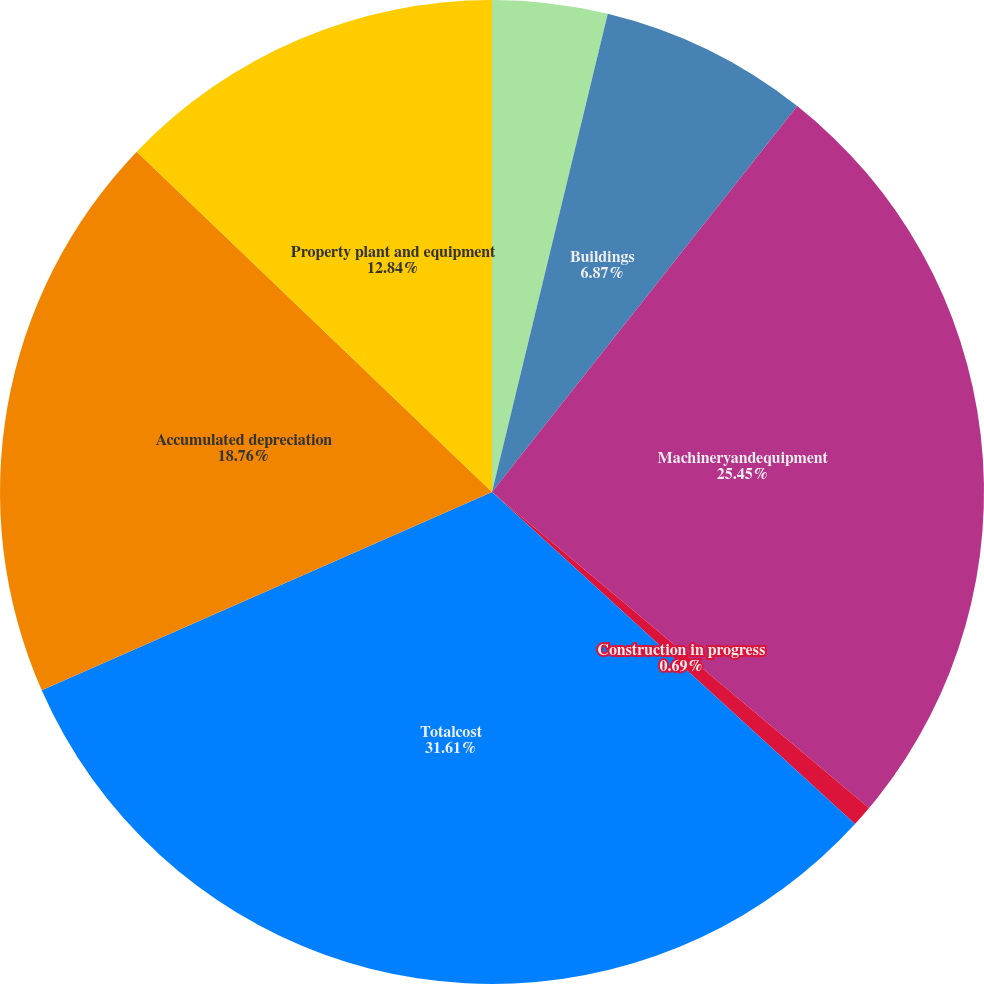Convert chart to OTSL. <chart><loc_0><loc_0><loc_500><loc_500><pie_chart><fcel>Landandlandimprovements<fcel>Buildings<fcel>Machineryandequipment<fcel>Construction in progress<fcel>Totalcost<fcel>Accumulated depreciation<fcel>Property plant and equipment<nl><fcel>3.78%<fcel>6.87%<fcel>25.45%<fcel>0.69%<fcel>31.6%<fcel>18.76%<fcel>12.84%<nl></chart> 